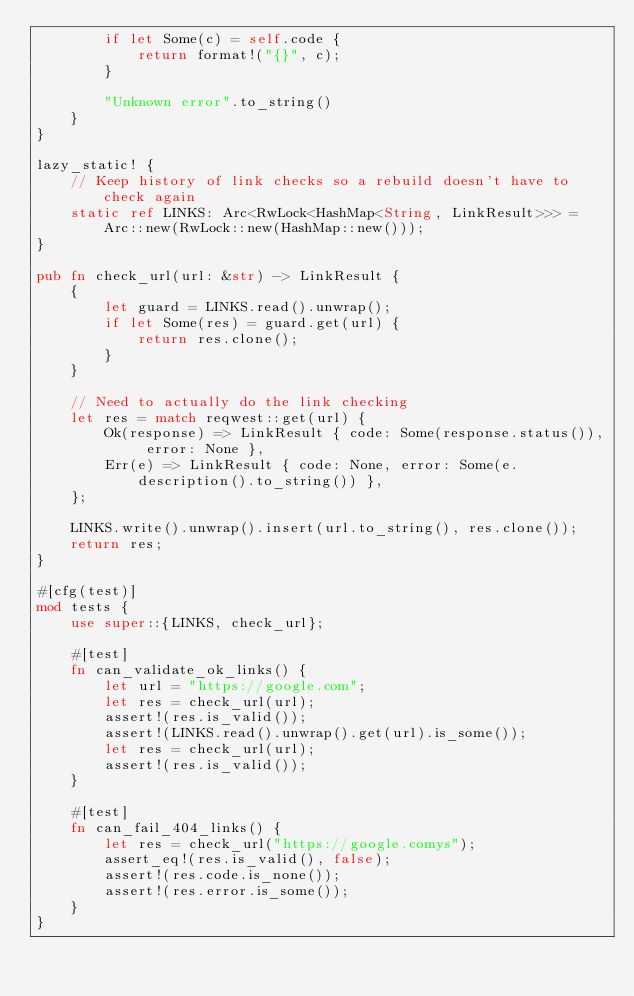<code> <loc_0><loc_0><loc_500><loc_500><_Rust_>        if let Some(c) = self.code {
            return format!("{}", c);
        }

        "Unknown error".to_string()
    }
}

lazy_static! {
    // Keep history of link checks so a rebuild doesn't have to check again
    static ref LINKS: Arc<RwLock<HashMap<String, LinkResult>>> = Arc::new(RwLock::new(HashMap::new()));
}

pub fn check_url(url: &str) -> LinkResult {
    {
        let guard = LINKS.read().unwrap();
        if let Some(res) = guard.get(url) {
            return res.clone();
        }
    }

    // Need to actually do the link checking
    let res = match reqwest::get(url) {
        Ok(response) => LinkResult { code: Some(response.status()), error: None },
        Err(e) => LinkResult { code: None, error: Some(e.description().to_string()) },
    };

    LINKS.write().unwrap().insert(url.to_string(), res.clone());
    return res;
}

#[cfg(test)]
mod tests {
    use super::{LINKS, check_url};

    #[test]
    fn can_validate_ok_links() {
        let url = "https://google.com";
        let res = check_url(url);
        assert!(res.is_valid());
        assert!(LINKS.read().unwrap().get(url).is_some());
        let res = check_url(url);
        assert!(res.is_valid());
    }

    #[test]
    fn can_fail_404_links() {
        let res = check_url("https://google.comys");
        assert_eq!(res.is_valid(), false);
        assert!(res.code.is_none());
        assert!(res.error.is_some());
    }
}
</code> 